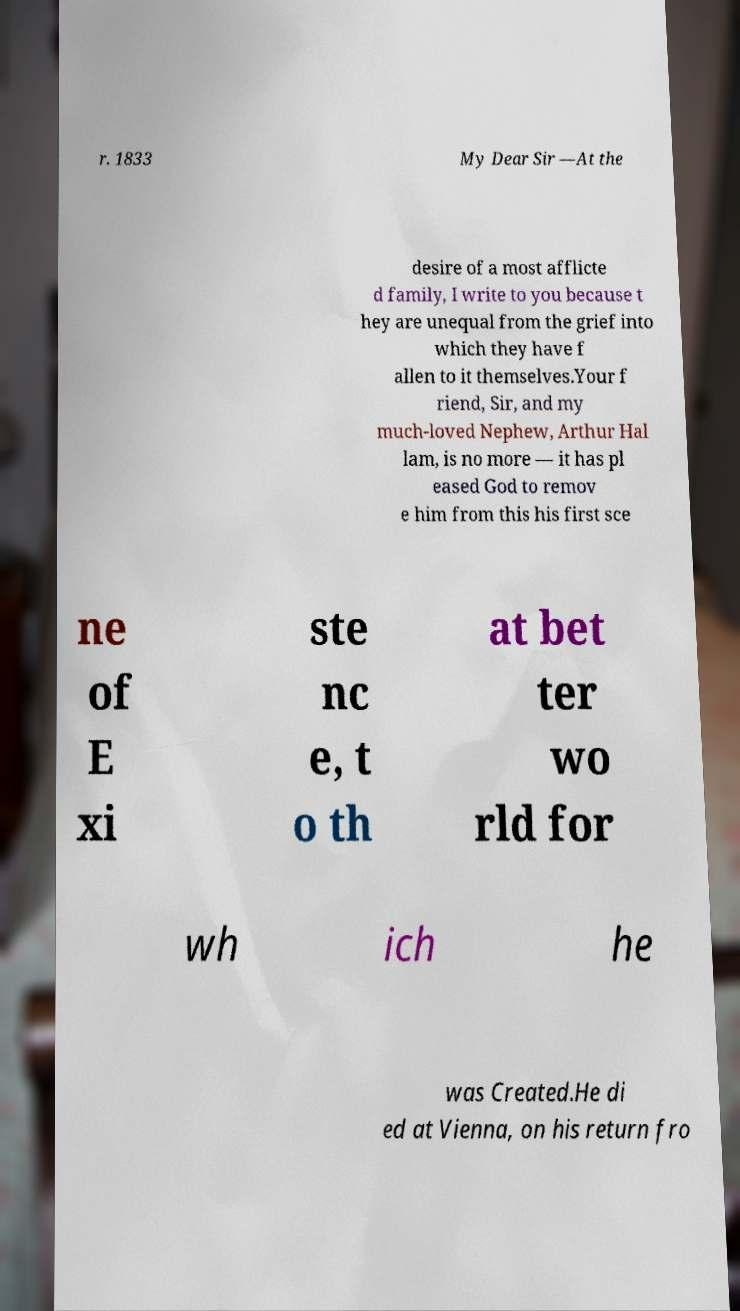Can you accurately transcribe the text from the provided image for me? r. 1833 My Dear Sir —At the desire of a most afflicte d family, I write to you because t hey are unequal from the grief into which they have f allen to it themselves.Your f riend, Sir, and my much-loved Nephew, Arthur Hal lam, is no more — it has pl eased God to remov e him from this his first sce ne of E xi ste nc e, t o th at bet ter wo rld for wh ich he was Created.He di ed at Vienna, on his return fro 